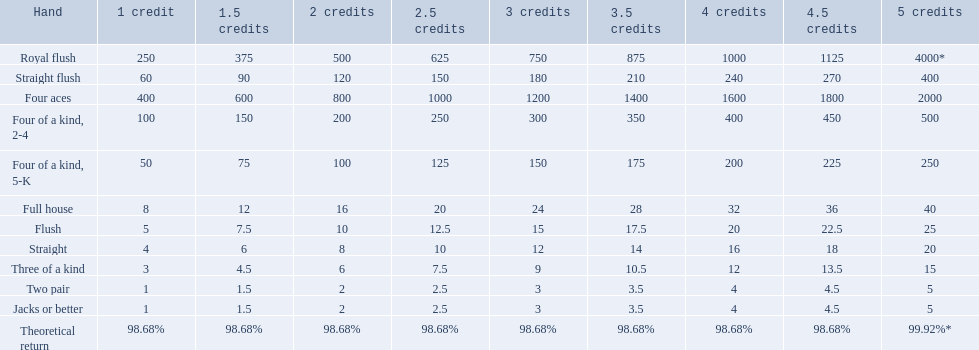What are each of the hands? Royal flush, Straight flush, Four aces, Four of a kind, 2-4, Four of a kind, 5-K, Full house, Flush, Straight, Three of a kind, Two pair, Jacks or better, Theoretical return. Which hand ranks higher between straights and flushes? Flush. 